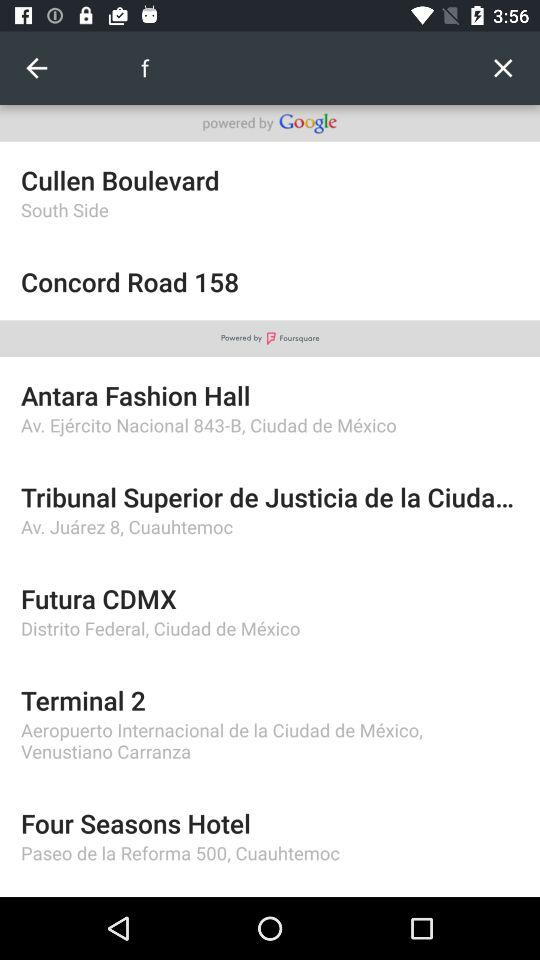How many items have the text 'powered by'?
Answer the question using a single word or phrase. 2 